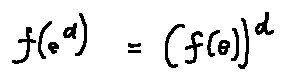<formula> <loc_0><loc_0><loc_500><loc_500>f ( e ^ { d } ) = ( f ( e ) ) ^ { d }</formula> 